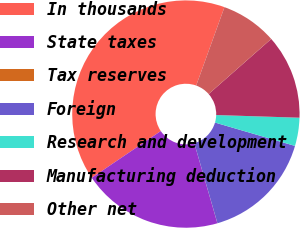Convert chart. <chart><loc_0><loc_0><loc_500><loc_500><pie_chart><fcel>In thousands<fcel>State taxes<fcel>Tax reserves<fcel>Foreign<fcel>Research and development<fcel>Manufacturing deduction<fcel>Other net<nl><fcel>39.98%<fcel>20.0%<fcel>0.01%<fcel>16.0%<fcel>4.01%<fcel>12.0%<fcel>8.0%<nl></chart> 